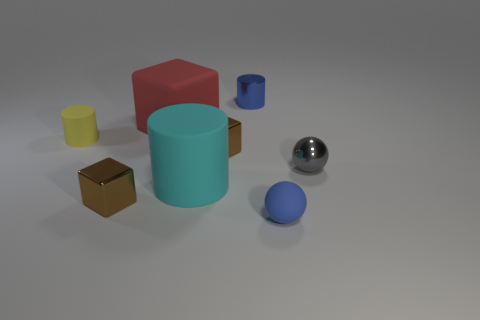Add 1 large green cylinders. How many objects exist? 9 Subtract all cylinders. How many objects are left? 5 Add 3 yellow objects. How many yellow objects are left? 4 Add 3 brown metallic blocks. How many brown metallic blocks exist? 5 Subtract 0 purple spheres. How many objects are left? 8 Subtract all small gray shiny spheres. Subtract all blue rubber objects. How many objects are left? 6 